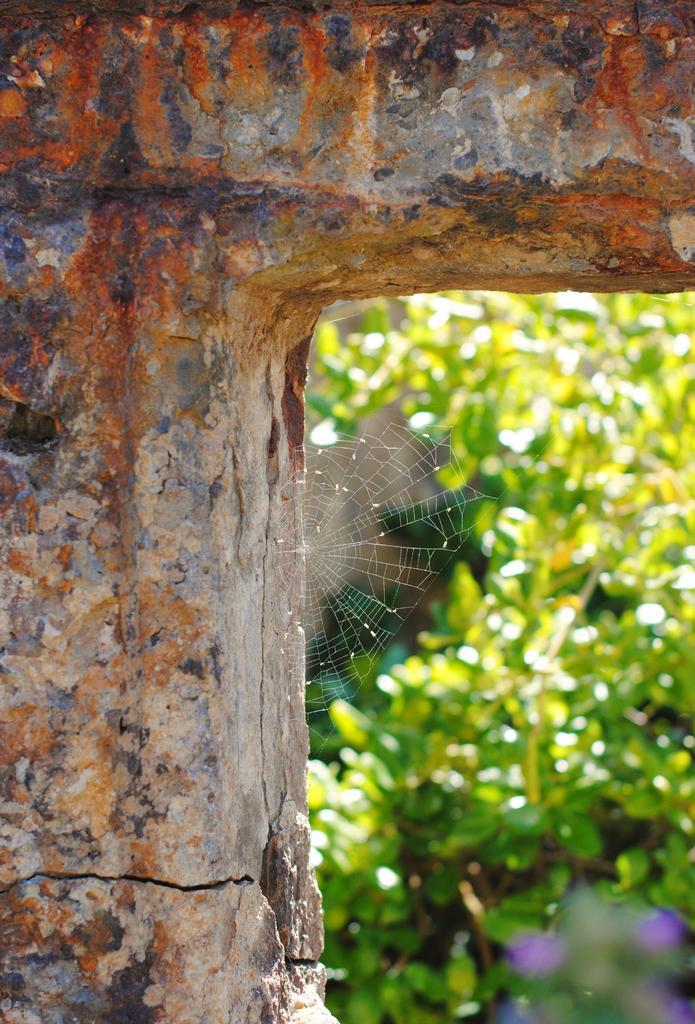How would you summarize this image in a sentence or two? In this image I can see there is a pillar, there is a spider web and in the background there are a few plants and it is blurred. 